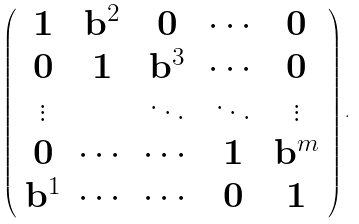<formula> <loc_0><loc_0><loc_500><loc_500>\left ( \begin{array} { c c c c c } \mathbf 1 & \mathbf b ^ { 2 } & \mathbf 0 & \cdots & \mathbf 0 \\ \mathbf 0 & \mathbf 1 & \mathbf b ^ { 3 } & \cdots & \mathbf 0 \\ \vdots & & \ddots & \ddots & \vdots \\ \mathbf 0 & \cdots & \cdots & \mathbf 1 & \mathbf b ^ { m } \\ \mathbf b ^ { 1 } & \cdots & \cdots & \mathbf 0 & \mathbf 1 \end{array} \right ) .</formula> 